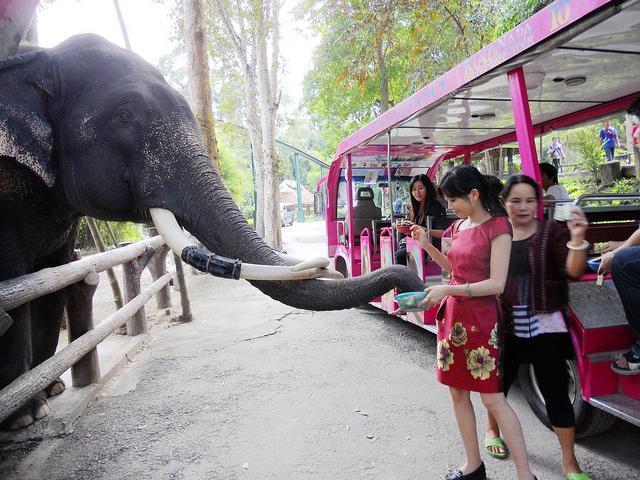What does the elephant seek?
Choose the correct response, then elucidate: 'Answer: answer
Rationale: rationale.'
Options: Friendship, food, mate, baby elephants. Answer: food.
Rationale: The woman has treats in the bowl 